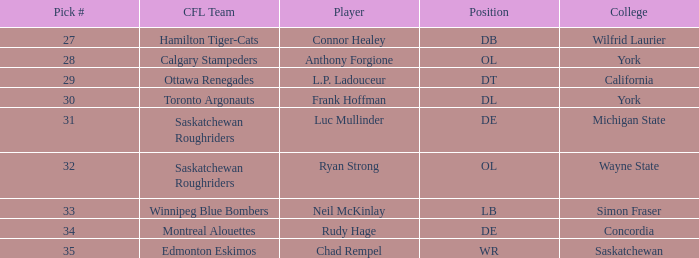What draft pick number do the edmonton eskimos have? 1.0. 